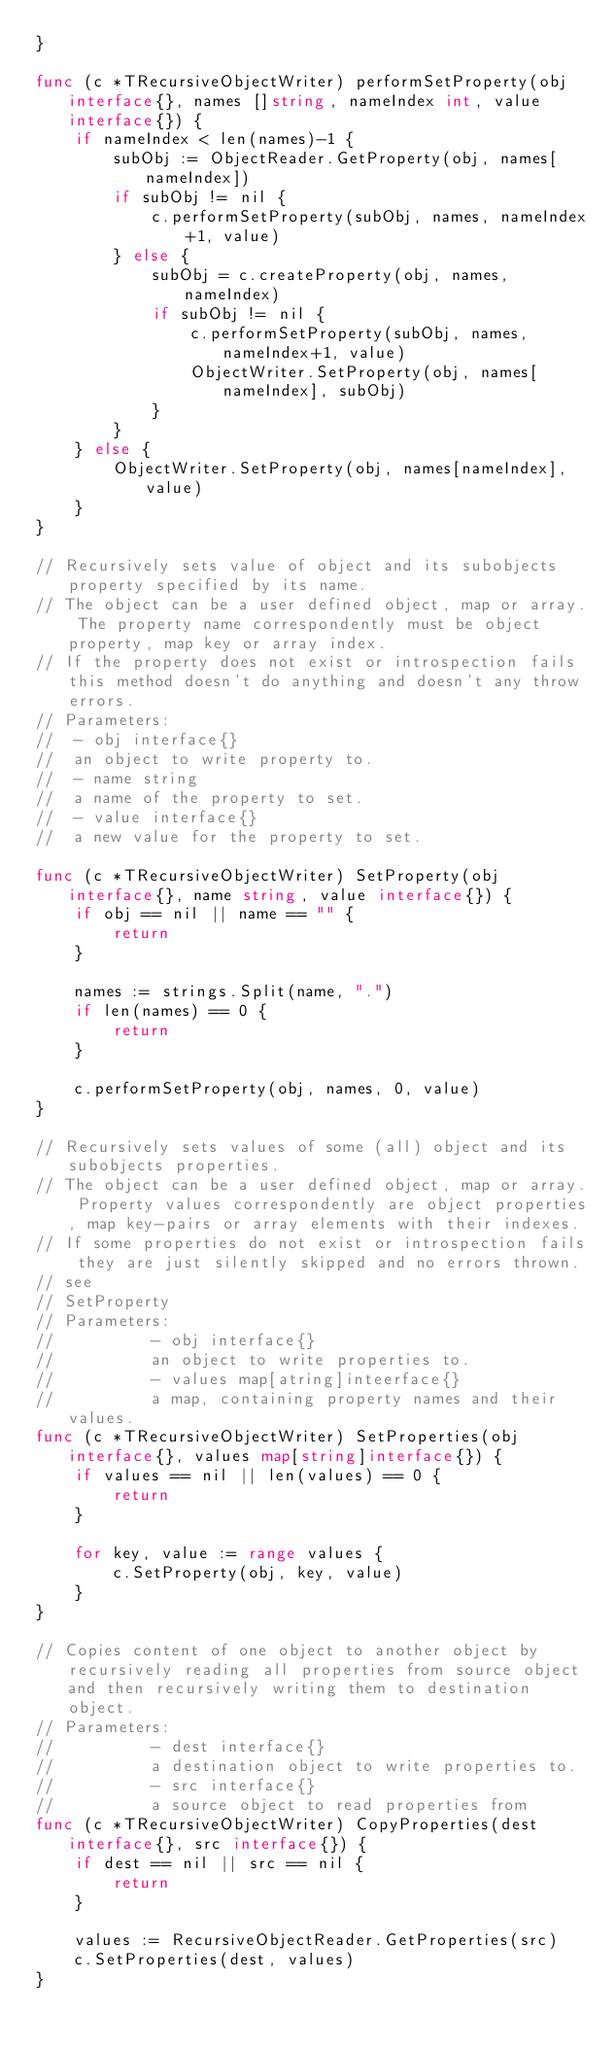<code> <loc_0><loc_0><loc_500><loc_500><_Go_>}

func (c *TRecursiveObjectWriter) performSetProperty(obj interface{}, names []string, nameIndex int, value interface{}) {
	if nameIndex < len(names)-1 {
		subObj := ObjectReader.GetProperty(obj, names[nameIndex])
		if subObj != nil {
			c.performSetProperty(subObj, names, nameIndex+1, value)
		} else {
			subObj = c.createProperty(obj, names, nameIndex)
			if subObj != nil {
				c.performSetProperty(subObj, names, nameIndex+1, value)
				ObjectWriter.SetProperty(obj, names[nameIndex], subObj)
			}
		}
	} else {
		ObjectWriter.SetProperty(obj, names[nameIndex], value)
	}
}

// Recursively sets value of object and its subobjects property specified by its name.
// The object can be a user defined object, map or array. The property name correspondently must be object property, map key or array index.
// If the property does not exist or introspection fails this method doesn't do anything and doesn't any throw errors.
// Parameters:
//  - obj interface{}
//  an object to write property to.
//  - name string
//  a name of the property to set.
//  - value interface{}
//  a new value for the property to set.

func (c *TRecursiveObjectWriter) SetProperty(obj interface{}, name string, value interface{}) {
	if obj == nil || name == "" {
		return
	}

	names := strings.Split(name, ".")
	if len(names) == 0 {
		return
	}

	c.performSetProperty(obj, names, 0, value)
}

// Recursively sets values of some (all) object and its subobjects properties.
// The object can be a user defined object, map or array. Property values correspondently are object properties, map key-pairs or array elements with their indexes.
// If some properties do not exist or introspection fails they are just silently skipped and no errors thrown.
// see
// SetProperty
// Parameters:
// 			- obj interface{}
// 			an object to write properties to.
// 			- values map[atring]inteerface{}
// 			a map, containing property names and their values.
func (c *TRecursiveObjectWriter) SetProperties(obj interface{}, values map[string]interface{}) {
	if values == nil || len(values) == 0 {
		return
	}

	for key, value := range values {
		c.SetProperty(obj, key, value)
	}
}

// Copies content of one object to another object by recursively reading all properties from source object and then recursively writing them to destination object.
// Parameters:
// 			- dest interface{}
// 			a destination object to write properties to.
// 			- src interface{}
// 			a source object to read properties from
func (c *TRecursiveObjectWriter) CopyProperties(dest interface{}, src interface{}) {
	if dest == nil || src == nil {
		return
	}

	values := RecursiveObjectReader.GetProperties(src)
	c.SetProperties(dest, values)
}
</code> 